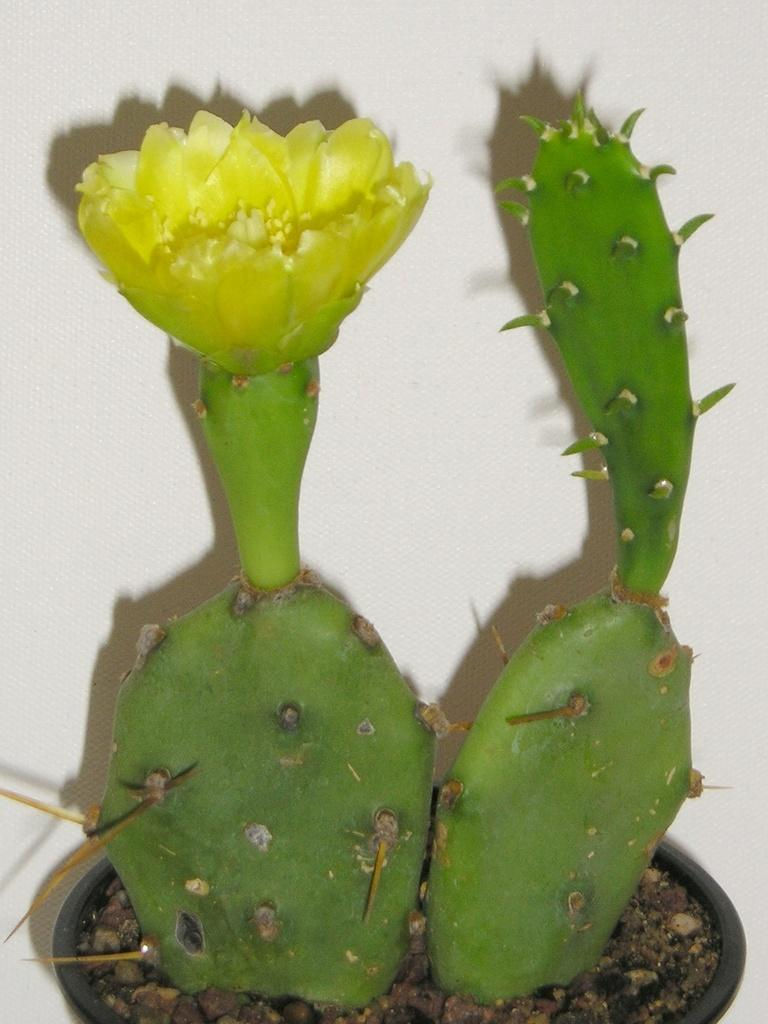What is in the pot in the image? There are two plants in a pot in the image. Are there any flowers on the plants? Yes, one of the plants has a flower. What can be seen in the background of the image? There is a white wall in the background of the image. What type of company is conducting a voyage in the image? There is no company or voyage present in the image; it features two plants in a pot and a white wall in the background. 